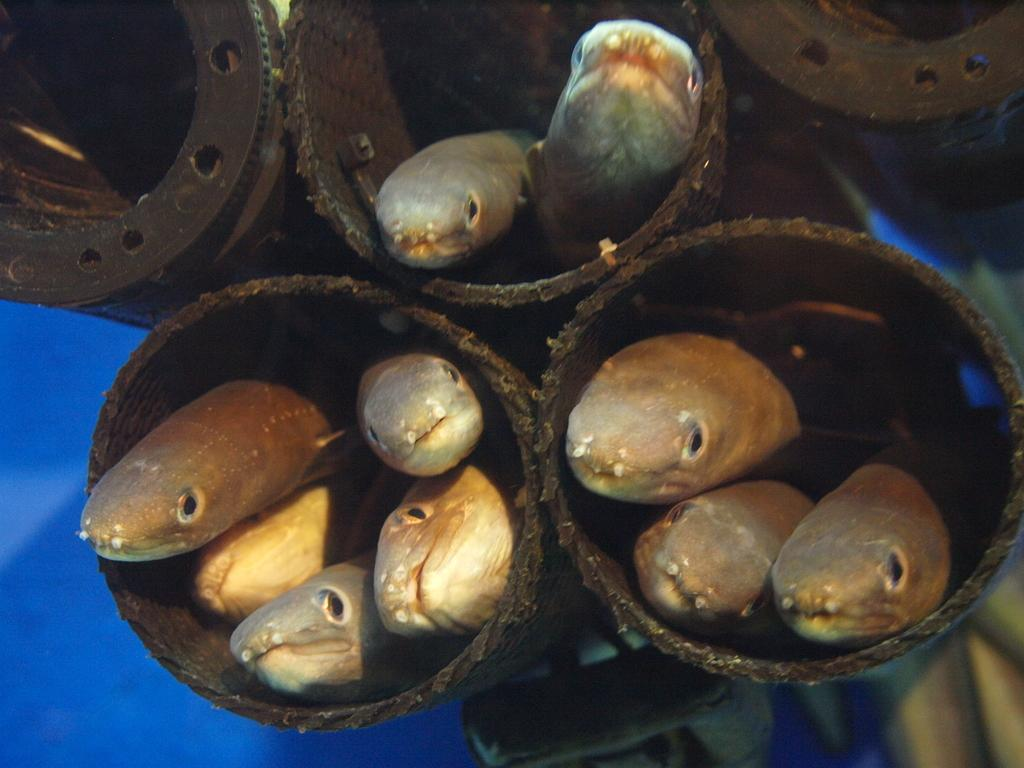What type of animals are present in the image? There are fishes in the image. Where are the fishes located? The fishes are in jars. Can you tell me how fast the dad runs in the image? There is no dad or running depicted in the image; it features fishes in jars. What type of crack is visible in the image? There is no crack present in the image; it features fishes in jars. 